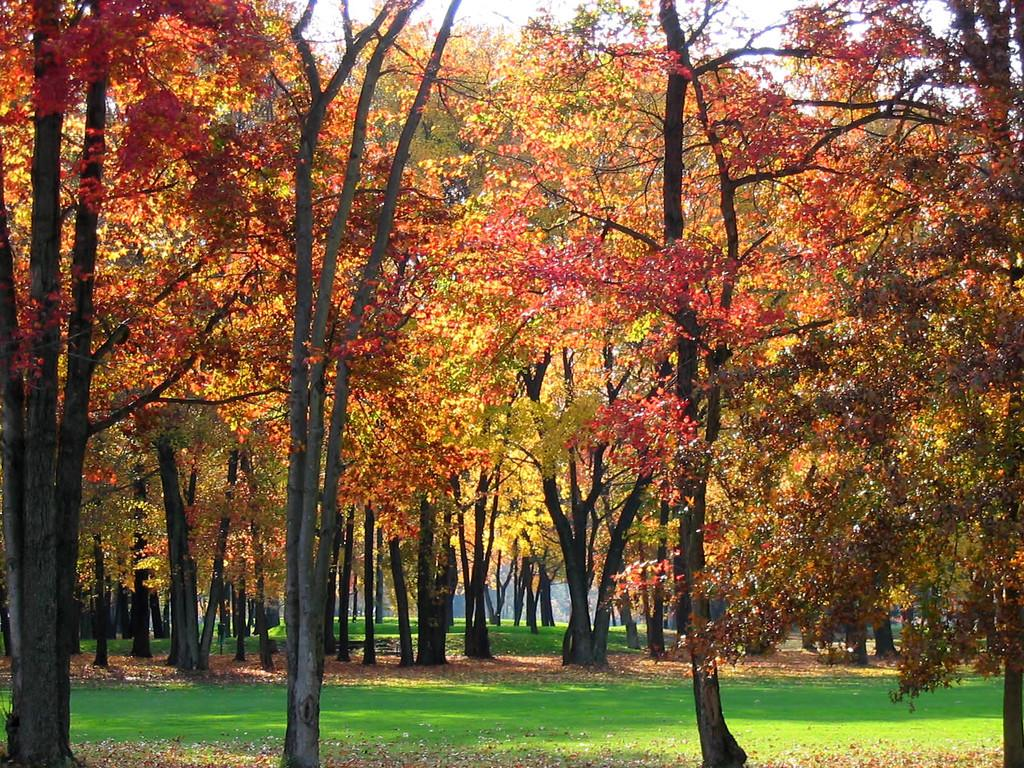What type of vegetation can be seen in the image? There are trees in the image. What is present at the bottom of the image? There are dry leaves and grass at the bottom of the image. What type of muscle can be seen flexing in the image? There is no muscle present in the image; it features trees, dry leaves, and grass. 